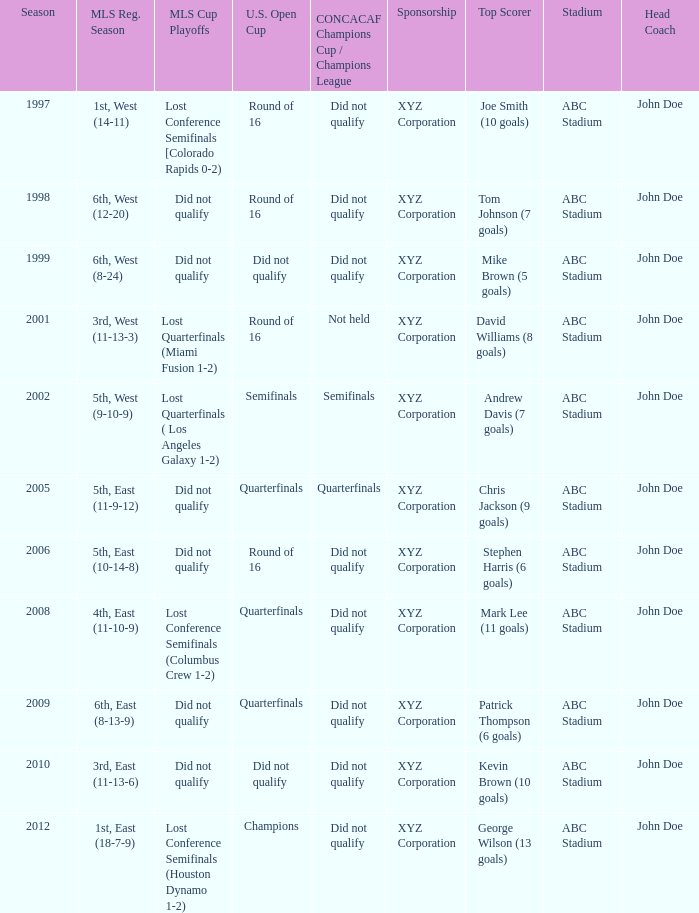When was the first season? 1997.0. 